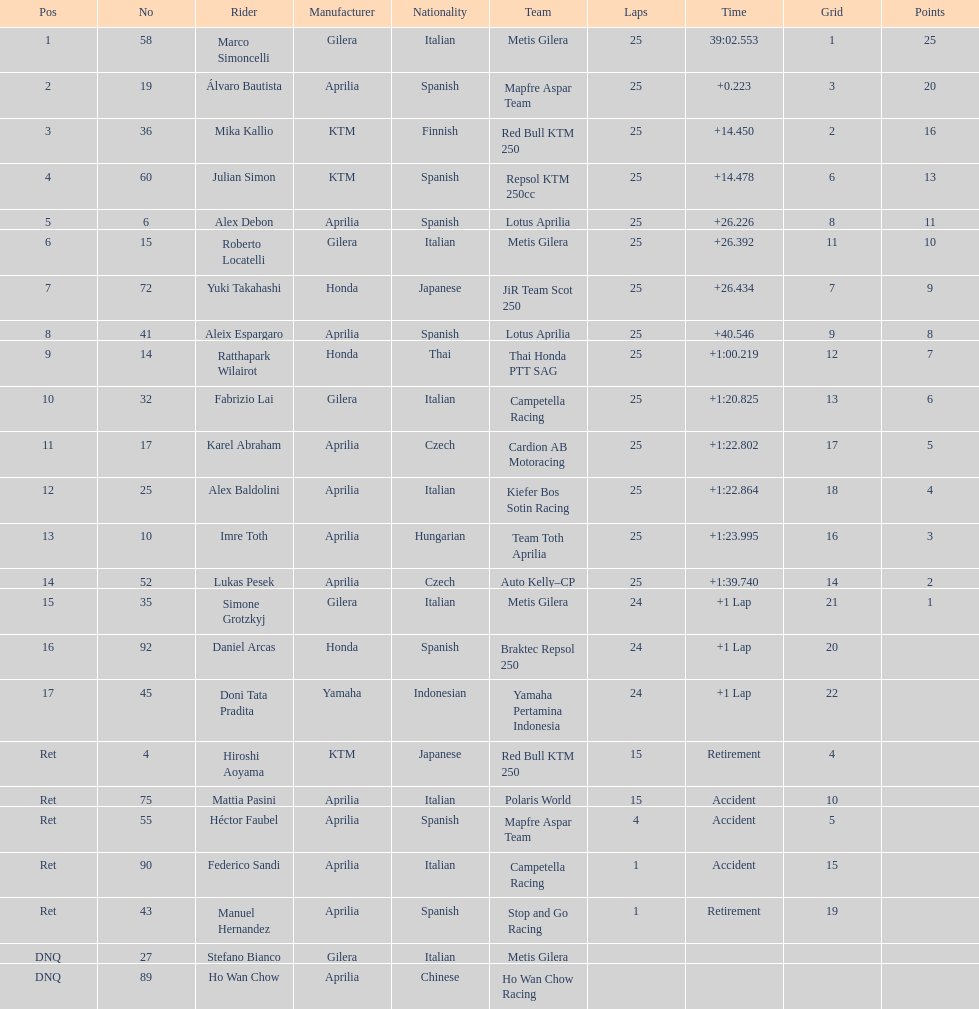Did marco simoncelli or alvaro bautista held rank 1? Marco Simoncelli. Write the full table. {'header': ['Pos', 'No', 'Rider', 'Manufacturer', 'Nationality', 'Team', 'Laps', 'Time', 'Grid', 'Points'], 'rows': [['1', '58', 'Marco Simoncelli', 'Gilera', 'Italian', 'Metis Gilera', '25', '39:02.553', '1', '25'], ['2', '19', 'Álvaro Bautista', 'Aprilia', 'Spanish', 'Mapfre Aspar Team', '25', '+0.223', '3', '20'], ['3', '36', 'Mika Kallio', 'KTM', 'Finnish', 'Red Bull KTM 250', '25', '+14.450', '2', '16'], ['4', '60', 'Julian Simon', 'KTM', 'Spanish', 'Repsol KTM 250cc', '25', '+14.478', '6', '13'], ['5', '6', 'Alex Debon', 'Aprilia', 'Spanish', 'Lotus Aprilia', '25', '+26.226', '8', '11'], ['6', '15', 'Roberto Locatelli', 'Gilera', 'Italian', 'Metis Gilera', '25', '+26.392', '11', '10'], ['7', '72', 'Yuki Takahashi', 'Honda', 'Japanese', 'JiR Team Scot 250', '25', '+26.434', '7', '9'], ['8', '41', 'Aleix Espargaro', 'Aprilia', 'Spanish', 'Lotus Aprilia', '25', '+40.546', '9', '8'], ['9', '14', 'Ratthapark Wilairot', 'Honda', 'Thai', 'Thai Honda PTT SAG', '25', '+1:00.219', '12', '7'], ['10', '32', 'Fabrizio Lai', 'Gilera', 'Italian', 'Campetella Racing', '25', '+1:20.825', '13', '6'], ['11', '17', 'Karel Abraham', 'Aprilia', 'Czech', 'Cardion AB Motoracing', '25', '+1:22.802', '17', '5'], ['12', '25', 'Alex Baldolini', 'Aprilia', 'Italian', 'Kiefer Bos Sotin Racing', '25', '+1:22.864', '18', '4'], ['13', '10', 'Imre Toth', 'Aprilia', 'Hungarian', 'Team Toth Aprilia', '25', '+1:23.995', '16', '3'], ['14', '52', 'Lukas Pesek', 'Aprilia', 'Czech', 'Auto Kelly–CP', '25', '+1:39.740', '14', '2'], ['15', '35', 'Simone Grotzkyj', 'Gilera', 'Italian', 'Metis Gilera', '24', '+1 Lap', '21', '1'], ['16', '92', 'Daniel Arcas', 'Honda', 'Spanish', 'Braktec Repsol 250', '24', '+1 Lap', '20', ''], ['17', '45', 'Doni Tata Pradita', 'Yamaha', 'Indonesian', 'Yamaha Pertamina Indonesia', '24', '+1 Lap', '22', ''], ['Ret', '4', 'Hiroshi Aoyama', 'KTM', 'Japanese', 'Red Bull KTM 250', '15', 'Retirement', '4', ''], ['Ret', '75', 'Mattia Pasini', 'Aprilia', 'Italian', 'Polaris World', '15', 'Accident', '10', ''], ['Ret', '55', 'Héctor Faubel', 'Aprilia', 'Spanish', 'Mapfre Aspar Team', '4', 'Accident', '5', ''], ['Ret', '90', 'Federico Sandi', 'Aprilia', 'Italian', 'Campetella Racing', '1', 'Accident', '15', ''], ['Ret', '43', 'Manuel Hernandez', 'Aprilia', 'Spanish', 'Stop and Go Racing', '1', 'Retirement', '19', ''], ['DNQ', '27', 'Stefano Bianco', 'Gilera', 'Italian', 'Metis Gilera', '', '', '', ''], ['DNQ', '89', 'Ho Wan Chow', 'Aprilia', 'Chinese', 'Ho Wan Chow Racing', '', '', '', '']]} 